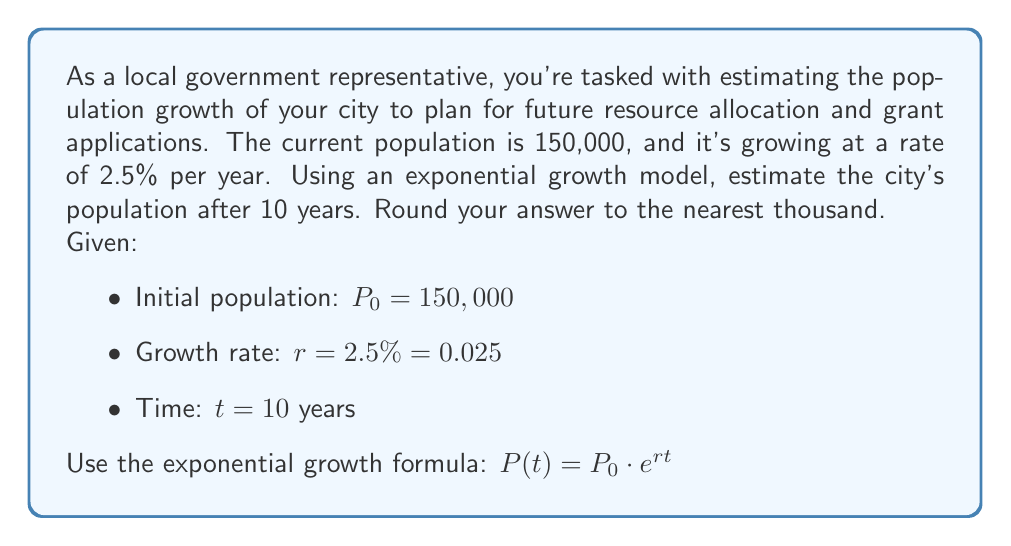Solve this math problem. To solve this problem, we'll use the exponential growth formula:

$P(t) = P_0 \cdot e^{rt}$

Where:
$P(t)$ is the population at time $t$
$P_0$ is the initial population
$e$ is Euler's number (approximately 2.71828)
$r$ is the growth rate (as a decimal)
$t$ is the time in years

Let's substitute the given values:

$P(10) = 150,000 \cdot e^{0.025 \cdot 10}$

Now, let's calculate step by step:

1. Simplify the exponent:
   $P(10) = 150,000 \cdot e^{0.25}$

2. Calculate $e^{0.25}$ (use a calculator):
   $e^{0.25} \approx 1.2840254166877414$

3. Multiply:
   $P(10) = 150,000 \cdot 1.2840254166877414$
   $P(10) = 192,603.81250316122$

4. Round to the nearest thousand:
   $P(10) \approx 193,000$

Therefore, the estimated population after 10 years is approximately 193,000 people.
Answer: 193,000 people 